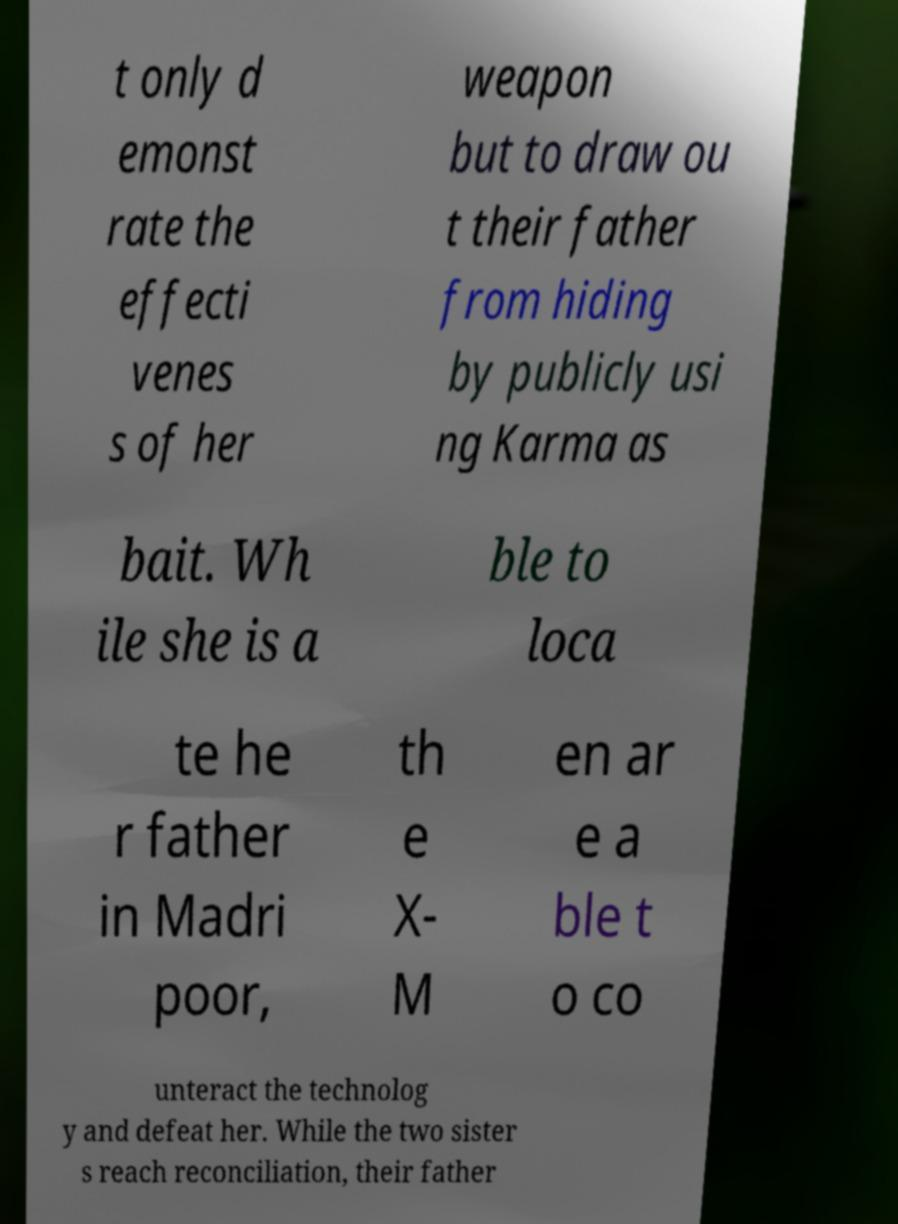There's text embedded in this image that I need extracted. Can you transcribe it verbatim? t only d emonst rate the effecti venes s of her weapon but to draw ou t their father from hiding by publicly usi ng Karma as bait. Wh ile she is a ble to loca te he r father in Madri poor, th e X- M en ar e a ble t o co unteract the technolog y and defeat her. While the two sister s reach reconciliation, their father 